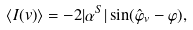<formula> <loc_0><loc_0><loc_500><loc_500>\langle { I ( v ) } \rangle = - 2 | \alpha ^ { S } | \sin ( \hat { \varphi } _ { v } - \varphi ) ,</formula> 